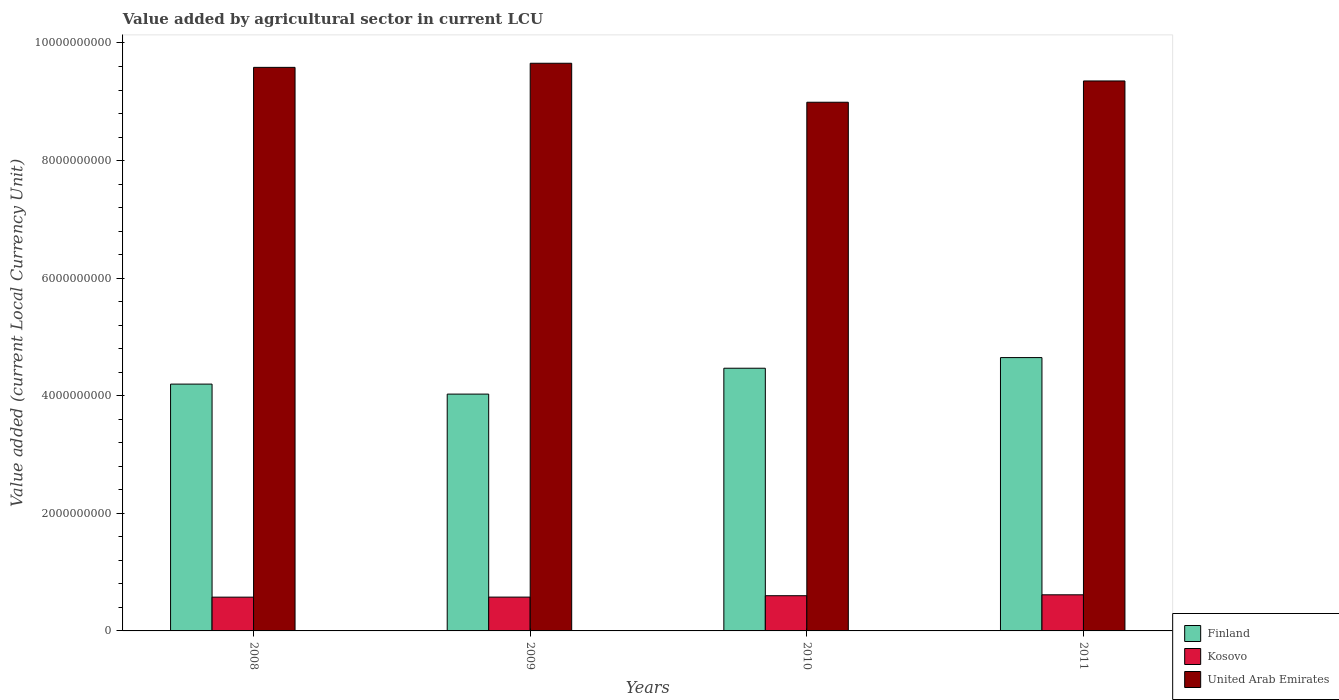How many groups of bars are there?
Make the answer very short. 4. How many bars are there on the 4th tick from the left?
Ensure brevity in your answer.  3. How many bars are there on the 4th tick from the right?
Your response must be concise. 3. In how many cases, is the number of bars for a given year not equal to the number of legend labels?
Make the answer very short. 0. What is the value added by agricultural sector in Kosovo in 2009?
Your response must be concise. 5.75e+08. Across all years, what is the maximum value added by agricultural sector in Kosovo?
Offer a very short reply. 6.14e+08. Across all years, what is the minimum value added by agricultural sector in Kosovo?
Your answer should be compact. 5.74e+08. In which year was the value added by agricultural sector in Finland maximum?
Your answer should be compact. 2011. What is the total value added by agricultural sector in Kosovo in the graph?
Give a very brief answer. 2.36e+09. What is the difference between the value added by agricultural sector in Kosovo in 2008 and that in 2011?
Ensure brevity in your answer.  -3.99e+07. What is the difference between the value added by agricultural sector in Kosovo in 2011 and the value added by agricultural sector in Finland in 2009?
Your answer should be very brief. -3.41e+09. What is the average value added by agricultural sector in Finland per year?
Your answer should be compact. 4.34e+09. In the year 2011, what is the difference between the value added by agricultural sector in Finland and value added by agricultural sector in Kosovo?
Provide a succinct answer. 4.03e+09. In how many years, is the value added by agricultural sector in United Arab Emirates greater than 8400000000 LCU?
Ensure brevity in your answer.  4. What is the ratio of the value added by agricultural sector in United Arab Emirates in 2009 to that in 2011?
Provide a succinct answer. 1.03. Is the difference between the value added by agricultural sector in Finland in 2008 and 2011 greater than the difference between the value added by agricultural sector in Kosovo in 2008 and 2011?
Make the answer very short. No. What is the difference between the highest and the second highest value added by agricultural sector in United Arab Emirates?
Offer a terse response. 7.00e+07. What is the difference between the highest and the lowest value added by agricultural sector in Kosovo?
Your response must be concise. 3.99e+07. In how many years, is the value added by agricultural sector in Kosovo greater than the average value added by agricultural sector in Kosovo taken over all years?
Provide a short and direct response. 2. Is the sum of the value added by agricultural sector in United Arab Emirates in 2008 and 2009 greater than the maximum value added by agricultural sector in Finland across all years?
Provide a short and direct response. Yes. What does the 2nd bar from the left in 2010 represents?
Give a very brief answer. Kosovo. What does the 2nd bar from the right in 2011 represents?
Ensure brevity in your answer.  Kosovo. Is it the case that in every year, the sum of the value added by agricultural sector in Finland and value added by agricultural sector in Kosovo is greater than the value added by agricultural sector in United Arab Emirates?
Your answer should be compact. No. How many years are there in the graph?
Your answer should be very brief. 4. What is the difference between two consecutive major ticks on the Y-axis?
Your answer should be very brief. 2.00e+09. Are the values on the major ticks of Y-axis written in scientific E-notation?
Offer a terse response. No. Does the graph contain any zero values?
Your answer should be compact. No. Where does the legend appear in the graph?
Ensure brevity in your answer.  Bottom right. What is the title of the graph?
Ensure brevity in your answer.  Value added by agricultural sector in current LCU. Does "Malta" appear as one of the legend labels in the graph?
Offer a terse response. No. What is the label or title of the Y-axis?
Provide a succinct answer. Value added (current Local Currency Unit). What is the Value added (current Local Currency Unit) of Finland in 2008?
Your response must be concise. 4.20e+09. What is the Value added (current Local Currency Unit) in Kosovo in 2008?
Give a very brief answer. 5.74e+08. What is the Value added (current Local Currency Unit) in United Arab Emirates in 2008?
Make the answer very short. 9.58e+09. What is the Value added (current Local Currency Unit) of Finland in 2009?
Your answer should be very brief. 4.03e+09. What is the Value added (current Local Currency Unit) of Kosovo in 2009?
Your answer should be compact. 5.75e+08. What is the Value added (current Local Currency Unit) of United Arab Emirates in 2009?
Provide a short and direct response. 9.66e+09. What is the Value added (current Local Currency Unit) in Finland in 2010?
Keep it short and to the point. 4.47e+09. What is the Value added (current Local Currency Unit) of Kosovo in 2010?
Ensure brevity in your answer.  5.99e+08. What is the Value added (current Local Currency Unit) in United Arab Emirates in 2010?
Your answer should be compact. 8.99e+09. What is the Value added (current Local Currency Unit) in Finland in 2011?
Your response must be concise. 4.65e+09. What is the Value added (current Local Currency Unit) of Kosovo in 2011?
Give a very brief answer. 6.14e+08. What is the Value added (current Local Currency Unit) in United Arab Emirates in 2011?
Make the answer very short. 9.35e+09. Across all years, what is the maximum Value added (current Local Currency Unit) in Finland?
Your answer should be very brief. 4.65e+09. Across all years, what is the maximum Value added (current Local Currency Unit) in Kosovo?
Offer a very short reply. 6.14e+08. Across all years, what is the maximum Value added (current Local Currency Unit) of United Arab Emirates?
Your answer should be very brief. 9.66e+09. Across all years, what is the minimum Value added (current Local Currency Unit) in Finland?
Ensure brevity in your answer.  4.03e+09. Across all years, what is the minimum Value added (current Local Currency Unit) of Kosovo?
Ensure brevity in your answer.  5.74e+08. Across all years, what is the minimum Value added (current Local Currency Unit) of United Arab Emirates?
Ensure brevity in your answer.  8.99e+09. What is the total Value added (current Local Currency Unit) of Finland in the graph?
Ensure brevity in your answer.  1.73e+1. What is the total Value added (current Local Currency Unit) of Kosovo in the graph?
Ensure brevity in your answer.  2.36e+09. What is the total Value added (current Local Currency Unit) in United Arab Emirates in the graph?
Provide a short and direct response. 3.76e+1. What is the difference between the Value added (current Local Currency Unit) in Finland in 2008 and that in 2009?
Provide a succinct answer. 1.70e+08. What is the difference between the Value added (current Local Currency Unit) of Kosovo in 2008 and that in 2009?
Offer a very short reply. -8.00e+05. What is the difference between the Value added (current Local Currency Unit) of United Arab Emirates in 2008 and that in 2009?
Your answer should be compact. -7.00e+07. What is the difference between the Value added (current Local Currency Unit) in Finland in 2008 and that in 2010?
Your response must be concise. -2.70e+08. What is the difference between the Value added (current Local Currency Unit) of Kosovo in 2008 and that in 2010?
Offer a very short reply. -2.44e+07. What is the difference between the Value added (current Local Currency Unit) of United Arab Emirates in 2008 and that in 2010?
Your answer should be very brief. 5.93e+08. What is the difference between the Value added (current Local Currency Unit) in Finland in 2008 and that in 2011?
Provide a succinct answer. -4.51e+08. What is the difference between the Value added (current Local Currency Unit) of Kosovo in 2008 and that in 2011?
Your answer should be very brief. -3.99e+07. What is the difference between the Value added (current Local Currency Unit) in United Arab Emirates in 2008 and that in 2011?
Ensure brevity in your answer.  2.31e+08. What is the difference between the Value added (current Local Currency Unit) of Finland in 2009 and that in 2010?
Make the answer very short. -4.40e+08. What is the difference between the Value added (current Local Currency Unit) of Kosovo in 2009 and that in 2010?
Make the answer very short. -2.36e+07. What is the difference between the Value added (current Local Currency Unit) of United Arab Emirates in 2009 and that in 2010?
Your answer should be compact. 6.63e+08. What is the difference between the Value added (current Local Currency Unit) of Finland in 2009 and that in 2011?
Your response must be concise. -6.21e+08. What is the difference between the Value added (current Local Currency Unit) of Kosovo in 2009 and that in 2011?
Provide a succinct answer. -3.91e+07. What is the difference between the Value added (current Local Currency Unit) in United Arab Emirates in 2009 and that in 2011?
Ensure brevity in your answer.  3.01e+08. What is the difference between the Value added (current Local Currency Unit) in Finland in 2010 and that in 2011?
Ensure brevity in your answer.  -1.81e+08. What is the difference between the Value added (current Local Currency Unit) in Kosovo in 2010 and that in 2011?
Give a very brief answer. -1.55e+07. What is the difference between the Value added (current Local Currency Unit) of United Arab Emirates in 2010 and that in 2011?
Offer a very short reply. -3.62e+08. What is the difference between the Value added (current Local Currency Unit) in Finland in 2008 and the Value added (current Local Currency Unit) in Kosovo in 2009?
Ensure brevity in your answer.  3.62e+09. What is the difference between the Value added (current Local Currency Unit) in Finland in 2008 and the Value added (current Local Currency Unit) in United Arab Emirates in 2009?
Your answer should be compact. -5.46e+09. What is the difference between the Value added (current Local Currency Unit) of Kosovo in 2008 and the Value added (current Local Currency Unit) of United Arab Emirates in 2009?
Keep it short and to the point. -9.08e+09. What is the difference between the Value added (current Local Currency Unit) in Finland in 2008 and the Value added (current Local Currency Unit) in Kosovo in 2010?
Offer a very short reply. 3.60e+09. What is the difference between the Value added (current Local Currency Unit) in Finland in 2008 and the Value added (current Local Currency Unit) in United Arab Emirates in 2010?
Keep it short and to the point. -4.79e+09. What is the difference between the Value added (current Local Currency Unit) in Kosovo in 2008 and the Value added (current Local Currency Unit) in United Arab Emirates in 2010?
Provide a succinct answer. -8.42e+09. What is the difference between the Value added (current Local Currency Unit) in Finland in 2008 and the Value added (current Local Currency Unit) in Kosovo in 2011?
Provide a succinct answer. 3.58e+09. What is the difference between the Value added (current Local Currency Unit) of Finland in 2008 and the Value added (current Local Currency Unit) of United Arab Emirates in 2011?
Your answer should be very brief. -5.16e+09. What is the difference between the Value added (current Local Currency Unit) in Kosovo in 2008 and the Value added (current Local Currency Unit) in United Arab Emirates in 2011?
Ensure brevity in your answer.  -8.78e+09. What is the difference between the Value added (current Local Currency Unit) in Finland in 2009 and the Value added (current Local Currency Unit) in Kosovo in 2010?
Offer a very short reply. 3.43e+09. What is the difference between the Value added (current Local Currency Unit) in Finland in 2009 and the Value added (current Local Currency Unit) in United Arab Emirates in 2010?
Ensure brevity in your answer.  -4.96e+09. What is the difference between the Value added (current Local Currency Unit) in Kosovo in 2009 and the Value added (current Local Currency Unit) in United Arab Emirates in 2010?
Give a very brief answer. -8.42e+09. What is the difference between the Value added (current Local Currency Unit) of Finland in 2009 and the Value added (current Local Currency Unit) of Kosovo in 2011?
Your response must be concise. 3.41e+09. What is the difference between the Value added (current Local Currency Unit) of Finland in 2009 and the Value added (current Local Currency Unit) of United Arab Emirates in 2011?
Provide a short and direct response. -5.33e+09. What is the difference between the Value added (current Local Currency Unit) of Kosovo in 2009 and the Value added (current Local Currency Unit) of United Arab Emirates in 2011?
Give a very brief answer. -8.78e+09. What is the difference between the Value added (current Local Currency Unit) of Finland in 2010 and the Value added (current Local Currency Unit) of Kosovo in 2011?
Give a very brief answer. 3.85e+09. What is the difference between the Value added (current Local Currency Unit) of Finland in 2010 and the Value added (current Local Currency Unit) of United Arab Emirates in 2011?
Make the answer very short. -4.89e+09. What is the difference between the Value added (current Local Currency Unit) of Kosovo in 2010 and the Value added (current Local Currency Unit) of United Arab Emirates in 2011?
Your response must be concise. -8.76e+09. What is the average Value added (current Local Currency Unit) in Finland per year?
Provide a short and direct response. 4.34e+09. What is the average Value added (current Local Currency Unit) in Kosovo per year?
Provide a short and direct response. 5.91e+08. What is the average Value added (current Local Currency Unit) of United Arab Emirates per year?
Make the answer very short. 9.40e+09. In the year 2008, what is the difference between the Value added (current Local Currency Unit) of Finland and Value added (current Local Currency Unit) of Kosovo?
Your answer should be compact. 3.62e+09. In the year 2008, what is the difference between the Value added (current Local Currency Unit) in Finland and Value added (current Local Currency Unit) in United Arab Emirates?
Offer a very short reply. -5.39e+09. In the year 2008, what is the difference between the Value added (current Local Currency Unit) in Kosovo and Value added (current Local Currency Unit) in United Arab Emirates?
Make the answer very short. -9.01e+09. In the year 2009, what is the difference between the Value added (current Local Currency Unit) in Finland and Value added (current Local Currency Unit) in Kosovo?
Make the answer very short. 3.45e+09. In the year 2009, what is the difference between the Value added (current Local Currency Unit) of Finland and Value added (current Local Currency Unit) of United Arab Emirates?
Your answer should be very brief. -5.63e+09. In the year 2009, what is the difference between the Value added (current Local Currency Unit) of Kosovo and Value added (current Local Currency Unit) of United Arab Emirates?
Provide a succinct answer. -9.08e+09. In the year 2010, what is the difference between the Value added (current Local Currency Unit) in Finland and Value added (current Local Currency Unit) in Kosovo?
Offer a very short reply. 3.87e+09. In the year 2010, what is the difference between the Value added (current Local Currency Unit) in Finland and Value added (current Local Currency Unit) in United Arab Emirates?
Give a very brief answer. -4.52e+09. In the year 2010, what is the difference between the Value added (current Local Currency Unit) in Kosovo and Value added (current Local Currency Unit) in United Arab Emirates?
Your response must be concise. -8.39e+09. In the year 2011, what is the difference between the Value added (current Local Currency Unit) of Finland and Value added (current Local Currency Unit) of Kosovo?
Your answer should be compact. 4.03e+09. In the year 2011, what is the difference between the Value added (current Local Currency Unit) of Finland and Value added (current Local Currency Unit) of United Arab Emirates?
Keep it short and to the point. -4.70e+09. In the year 2011, what is the difference between the Value added (current Local Currency Unit) in Kosovo and Value added (current Local Currency Unit) in United Arab Emirates?
Provide a short and direct response. -8.74e+09. What is the ratio of the Value added (current Local Currency Unit) of Finland in 2008 to that in 2009?
Your answer should be compact. 1.04. What is the ratio of the Value added (current Local Currency Unit) in Kosovo in 2008 to that in 2009?
Keep it short and to the point. 1. What is the ratio of the Value added (current Local Currency Unit) of Finland in 2008 to that in 2010?
Your response must be concise. 0.94. What is the ratio of the Value added (current Local Currency Unit) of Kosovo in 2008 to that in 2010?
Provide a succinct answer. 0.96. What is the ratio of the Value added (current Local Currency Unit) in United Arab Emirates in 2008 to that in 2010?
Your response must be concise. 1.07. What is the ratio of the Value added (current Local Currency Unit) in Finland in 2008 to that in 2011?
Provide a succinct answer. 0.9. What is the ratio of the Value added (current Local Currency Unit) of Kosovo in 2008 to that in 2011?
Make the answer very short. 0.94. What is the ratio of the Value added (current Local Currency Unit) of United Arab Emirates in 2008 to that in 2011?
Your answer should be very brief. 1.02. What is the ratio of the Value added (current Local Currency Unit) in Finland in 2009 to that in 2010?
Ensure brevity in your answer.  0.9. What is the ratio of the Value added (current Local Currency Unit) of Kosovo in 2009 to that in 2010?
Ensure brevity in your answer.  0.96. What is the ratio of the Value added (current Local Currency Unit) in United Arab Emirates in 2009 to that in 2010?
Offer a terse response. 1.07. What is the ratio of the Value added (current Local Currency Unit) of Finland in 2009 to that in 2011?
Provide a short and direct response. 0.87. What is the ratio of the Value added (current Local Currency Unit) in Kosovo in 2009 to that in 2011?
Ensure brevity in your answer.  0.94. What is the ratio of the Value added (current Local Currency Unit) of United Arab Emirates in 2009 to that in 2011?
Make the answer very short. 1.03. What is the ratio of the Value added (current Local Currency Unit) in Finland in 2010 to that in 2011?
Provide a short and direct response. 0.96. What is the ratio of the Value added (current Local Currency Unit) in Kosovo in 2010 to that in 2011?
Your answer should be very brief. 0.97. What is the ratio of the Value added (current Local Currency Unit) in United Arab Emirates in 2010 to that in 2011?
Provide a short and direct response. 0.96. What is the difference between the highest and the second highest Value added (current Local Currency Unit) of Finland?
Your answer should be compact. 1.81e+08. What is the difference between the highest and the second highest Value added (current Local Currency Unit) in Kosovo?
Your answer should be compact. 1.55e+07. What is the difference between the highest and the second highest Value added (current Local Currency Unit) of United Arab Emirates?
Offer a terse response. 7.00e+07. What is the difference between the highest and the lowest Value added (current Local Currency Unit) in Finland?
Make the answer very short. 6.21e+08. What is the difference between the highest and the lowest Value added (current Local Currency Unit) in Kosovo?
Your response must be concise. 3.99e+07. What is the difference between the highest and the lowest Value added (current Local Currency Unit) in United Arab Emirates?
Provide a short and direct response. 6.63e+08. 